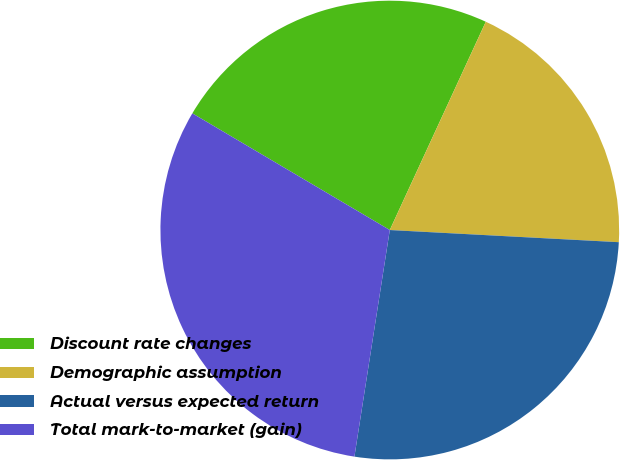Convert chart to OTSL. <chart><loc_0><loc_0><loc_500><loc_500><pie_chart><fcel>Discount rate changes<fcel>Demographic assumption<fcel>Actual versus expected return<fcel>Total mark-to-market (gain)<nl><fcel>23.38%<fcel>18.97%<fcel>26.62%<fcel>31.03%<nl></chart> 